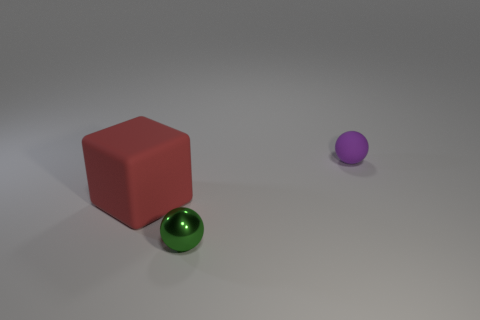Add 1 big blue metallic spheres. How many objects exist? 4 Subtract all cubes. How many objects are left? 2 Subtract 0 green cylinders. How many objects are left? 3 Subtract all big red things. Subtract all cyan shiny spheres. How many objects are left? 2 Add 3 rubber things. How many rubber things are left? 5 Add 1 yellow metal blocks. How many yellow metal blocks exist? 1 